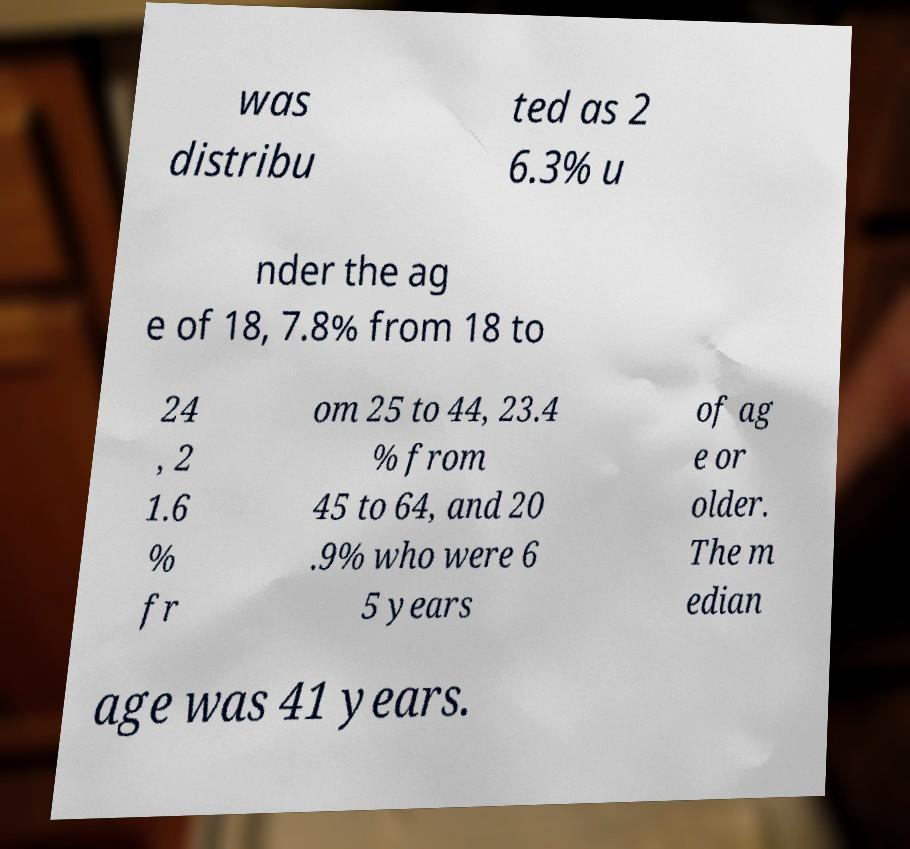Could you assist in decoding the text presented in this image and type it out clearly? was distribu ted as 2 6.3% u nder the ag e of 18, 7.8% from 18 to 24 , 2 1.6 % fr om 25 to 44, 23.4 % from 45 to 64, and 20 .9% who were 6 5 years of ag e or older. The m edian age was 41 years. 